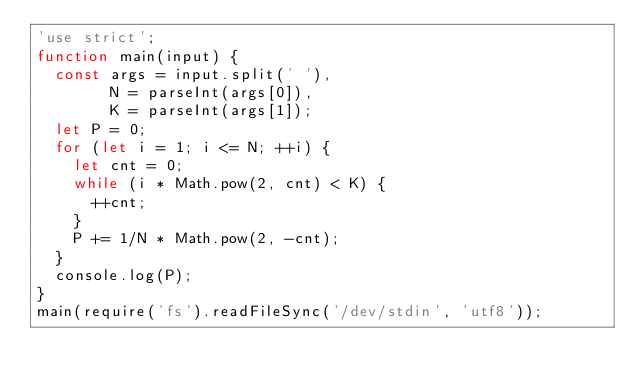<code> <loc_0><loc_0><loc_500><loc_500><_JavaScript_>'use strict';
function main(input) {
  const args = input.split(' '),
        N = parseInt(args[0]),
        K = parseInt(args[1]);
  let P = 0;
  for (let i = 1; i <= N; ++i) {
    let cnt = 0;
    while (i * Math.pow(2, cnt) < K) {
      ++cnt;
    }
    P += 1/N * Math.pow(2, -cnt);
  }
  console.log(P);
}
main(require('fs').readFileSync('/dev/stdin', 'utf8'));</code> 